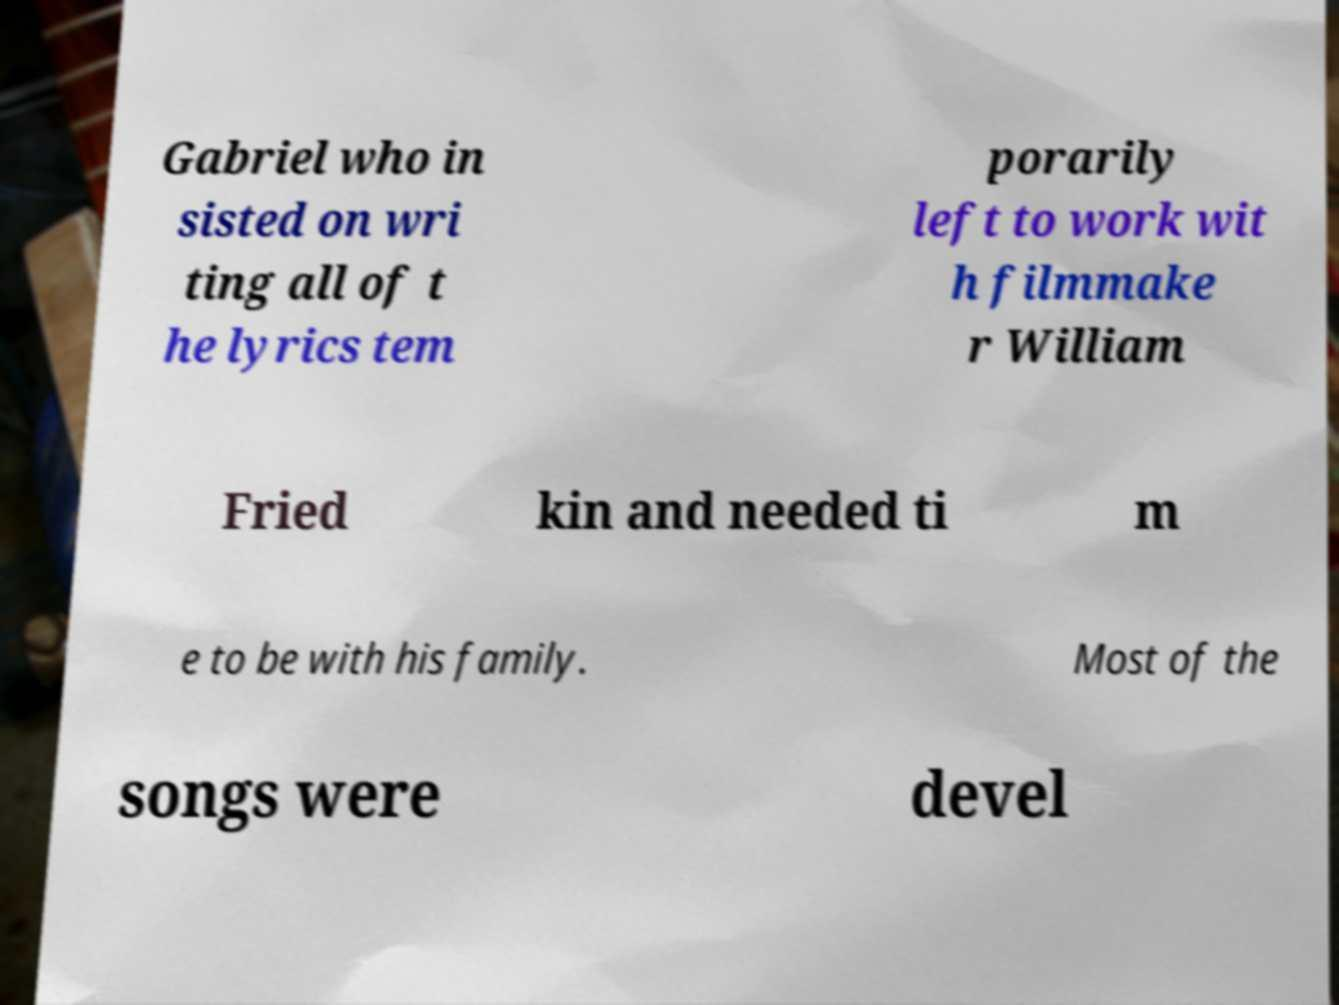For documentation purposes, I need the text within this image transcribed. Could you provide that? Gabriel who in sisted on wri ting all of t he lyrics tem porarily left to work wit h filmmake r William Fried kin and needed ti m e to be with his family. Most of the songs were devel 